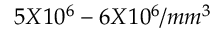<formula> <loc_0><loc_0><loc_500><loc_500>5 X 1 0 ^ { 6 } - 6 X 1 0 ^ { 6 } / m m ^ { 3 }</formula> 